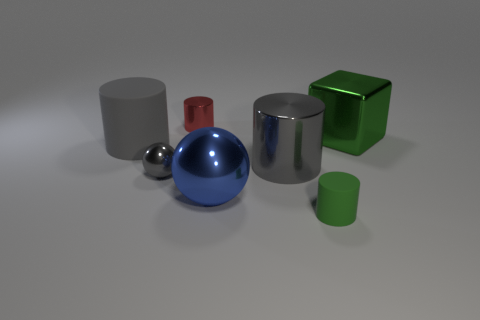Subtract all blue balls. How many gray cylinders are left? 2 Subtract all green cylinders. How many cylinders are left? 3 Add 3 small red metal things. How many objects exist? 10 Subtract all red cylinders. How many cylinders are left? 3 Subtract all cylinders. How many objects are left? 3 Subtract 0 purple balls. How many objects are left? 7 Subtract all blue cylinders. Subtract all yellow spheres. How many cylinders are left? 4 Subtract all shiny cylinders. Subtract all tiny gray balls. How many objects are left? 4 Add 1 large shiny things. How many large shiny things are left? 4 Add 2 large blue metallic objects. How many large blue metallic objects exist? 3 